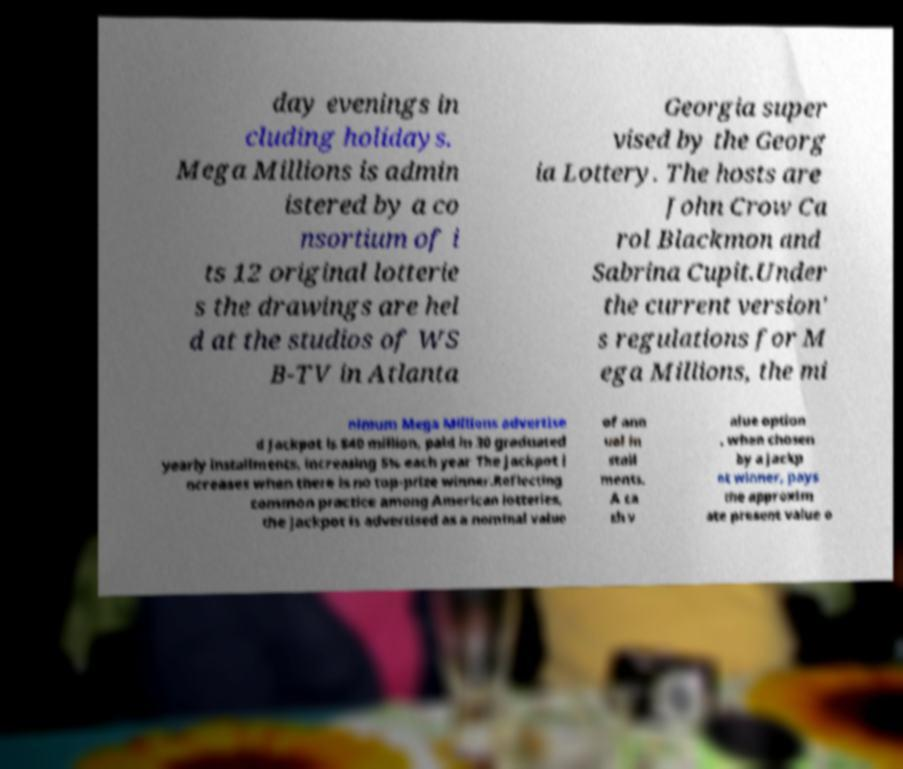Please identify and transcribe the text found in this image. day evenings in cluding holidays. Mega Millions is admin istered by a co nsortium of i ts 12 original lotterie s the drawings are hel d at the studios of WS B-TV in Atlanta Georgia super vised by the Georg ia Lottery. The hosts are John Crow Ca rol Blackmon and Sabrina Cupit.Under the current version' s regulations for M ega Millions, the mi nimum Mega Millions advertise d jackpot is $40 million, paid in 30 graduated yearly installments, increasing 5% each year The jackpot i ncreases when there is no top-prize winner.Reflecting common practice among American lotteries, the jackpot is advertised as a nominal value of ann ual in stall ments. A ca sh v alue option , when chosen by a jackp ot winner, pays the approxim ate present value o 